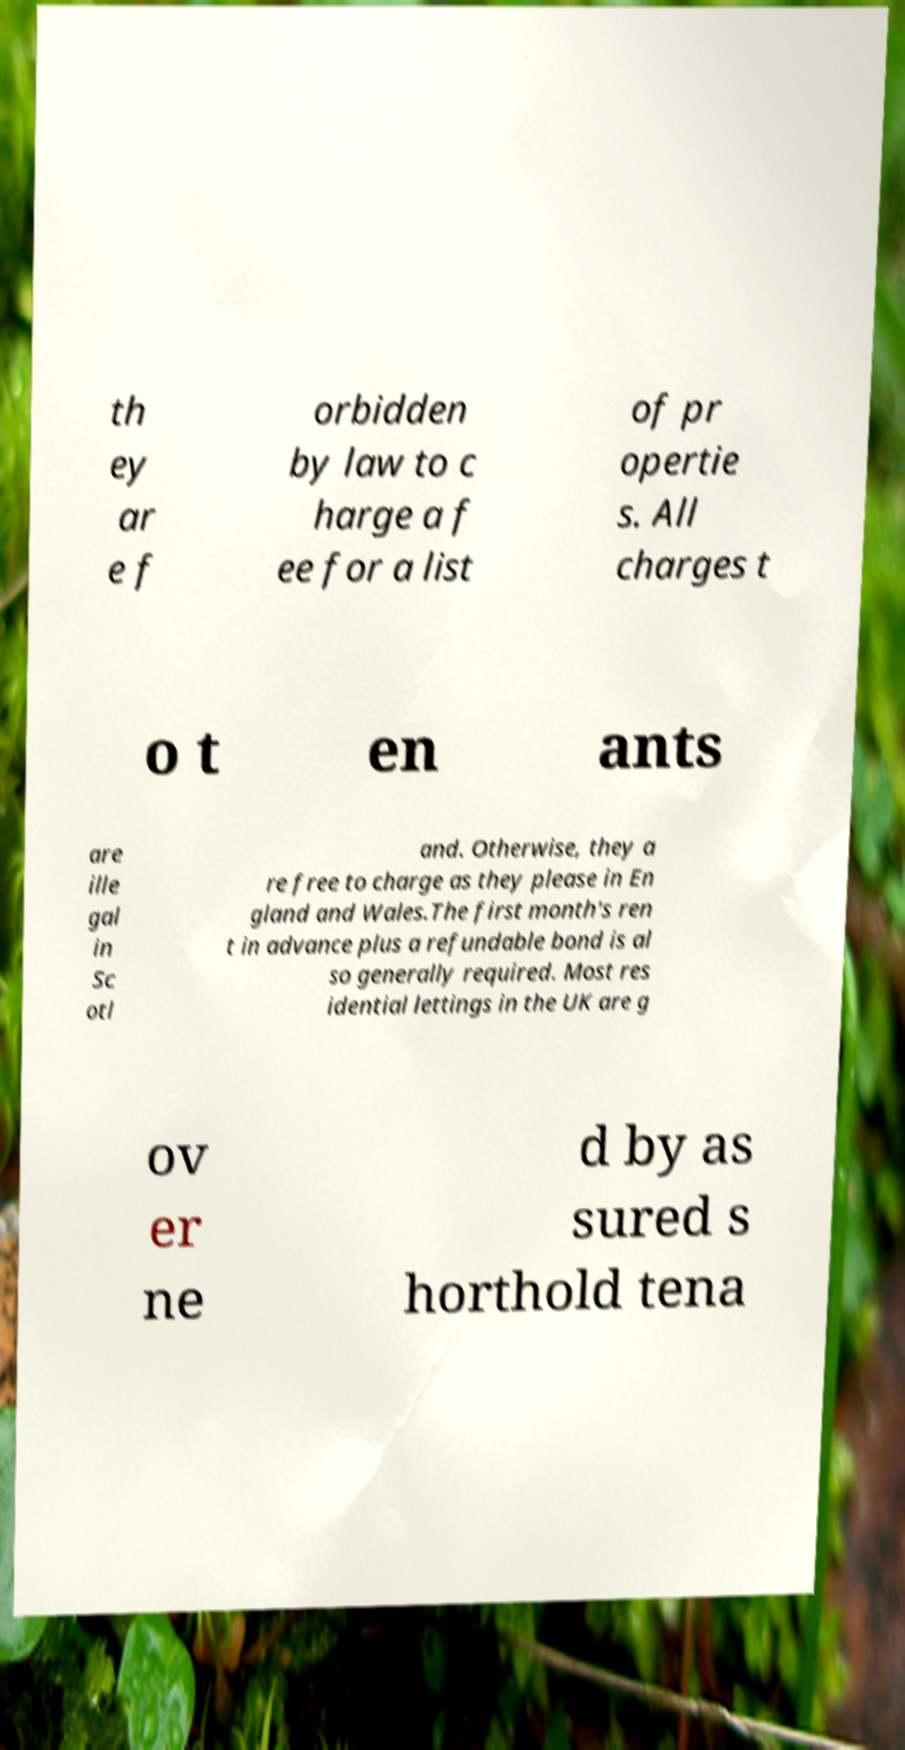What messages or text are displayed in this image? I need them in a readable, typed format. th ey ar e f orbidden by law to c harge a f ee for a list of pr opertie s. All charges t o t en ants are ille gal in Sc otl and. Otherwise, they a re free to charge as they please in En gland and Wales.The first month's ren t in advance plus a refundable bond is al so generally required. Most res idential lettings in the UK are g ov er ne d by as sured s horthold tena 